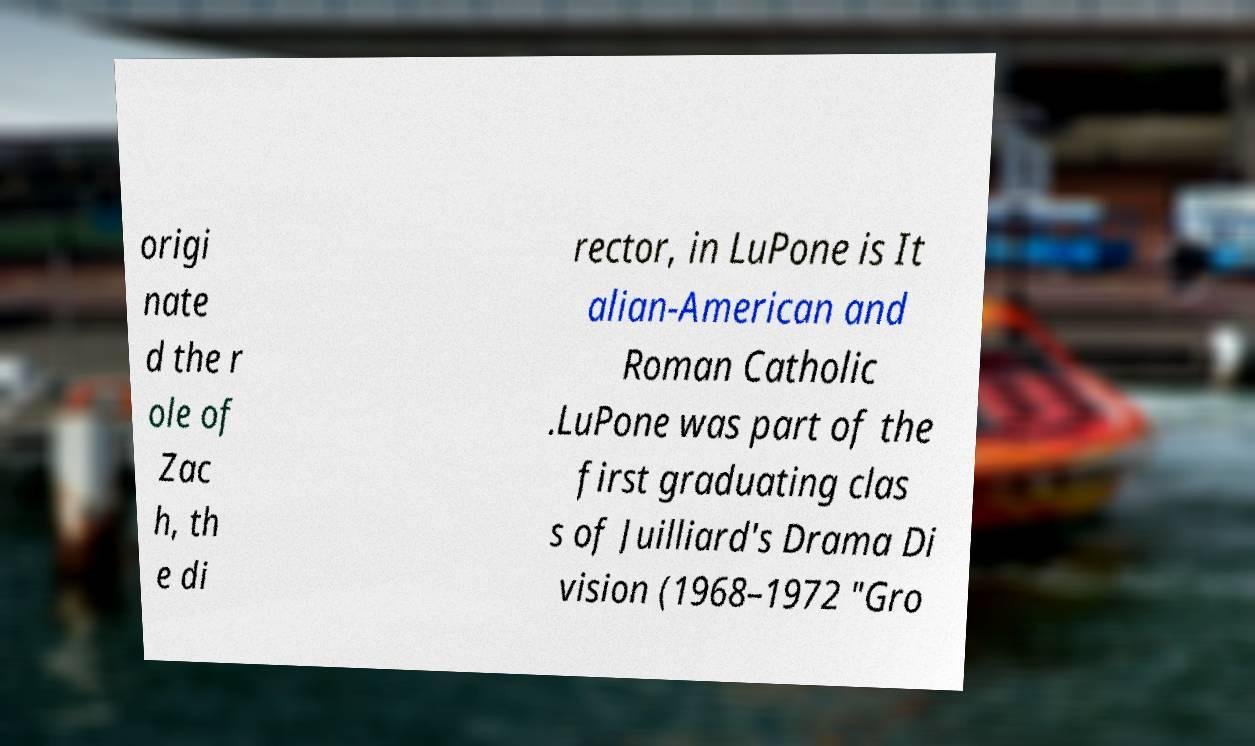Could you assist in decoding the text presented in this image and type it out clearly? origi nate d the r ole of Zac h, th e di rector, in LuPone is It alian-American and Roman Catholic .LuPone was part of the first graduating clas s of Juilliard's Drama Di vision (1968–1972 "Gro 